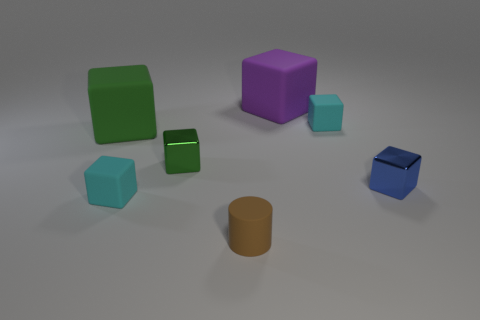What is the small cyan object in front of the metal cube to the right of the tiny cyan rubber thing behind the tiny blue block made of?
Offer a terse response. Rubber. Do the large green object and the purple matte object have the same shape?
Ensure brevity in your answer.  Yes. What number of metallic objects are blue cylinders or large things?
Provide a succinct answer. 0. What number of purple metallic things are there?
Offer a terse response. 0. What color is the cylinder that is the same size as the green metallic block?
Ensure brevity in your answer.  Brown. Is the size of the brown matte cylinder the same as the blue shiny thing?
Give a very brief answer. Yes. Is the size of the blue block the same as the purple thing that is right of the cylinder?
Make the answer very short. No. What color is the matte cube that is both behind the green shiny object and left of the small brown cylinder?
Keep it short and to the point. Green. Is the number of tiny rubber things that are on the right side of the cylinder greater than the number of large cubes in front of the tiny blue metal thing?
Offer a very short reply. Yes. There is a green object that is the same material as the purple thing; what is its size?
Your response must be concise. Large. 